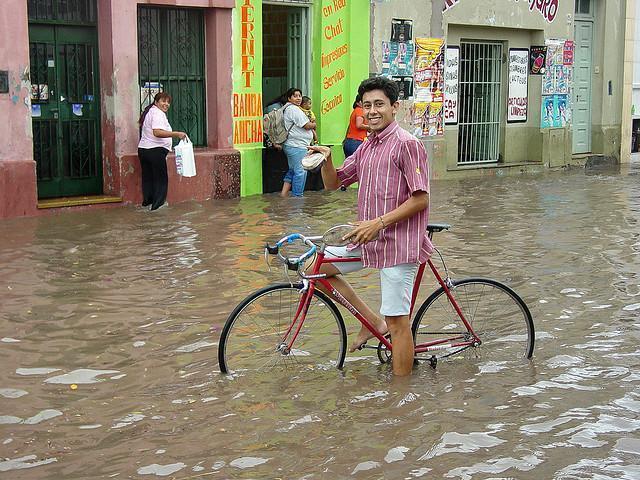Where is the man in?
Choose the right answer from the provided options to respond to the question.
Options: Pool, street, yard, playground. Street. 